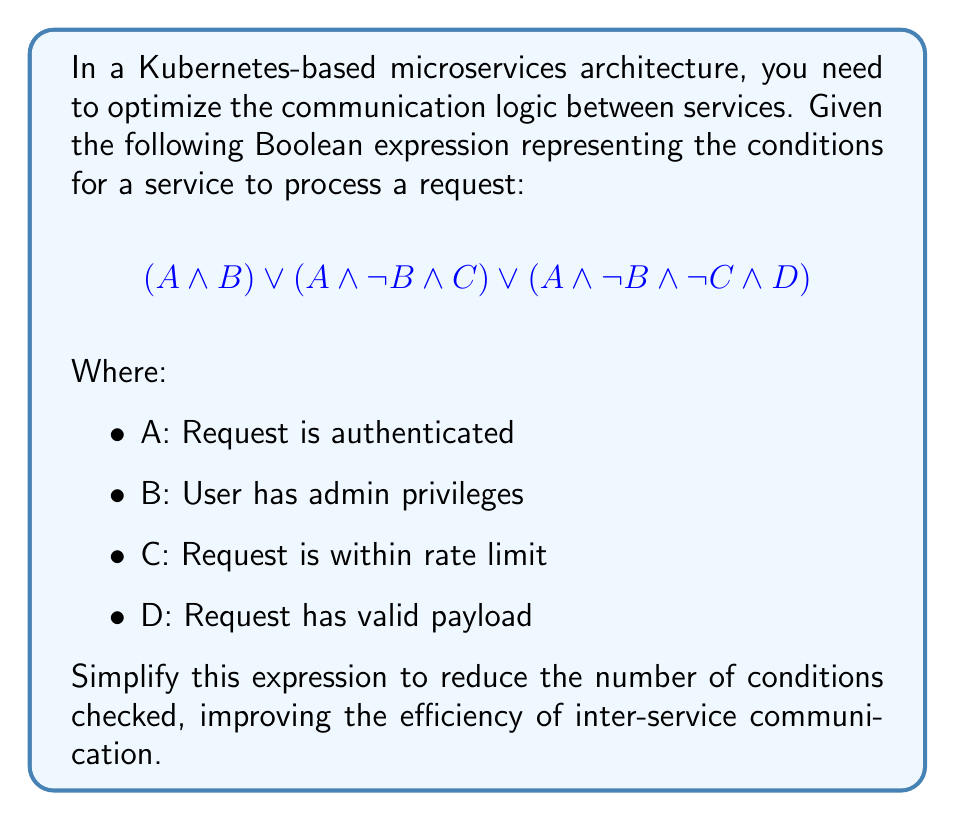Teach me how to tackle this problem. Let's simplify this expression step by step using Boolean algebra laws:

1) First, we can factor out A from all terms:
   $$A \land (B \lor (\lnot B \land C) \lor (\lnot B \land \lnot C \land D))$$

2) Now, let's focus on the part inside the parentheses:
   $$B \lor (\lnot B \land C) \lor (\lnot B \land \lnot C \land D)$$

3) We can apply the distributive law to the second and third terms:
   $$B \lor (\lnot B \land (C \lor (\lnot C \land D)))$$

4) Simplify the innermost parentheses using the absorption law:
   $$C \lor (\lnot C \land D) = C \lor D$$

5) Our expression now looks like:
   $$B \lor (\lnot B \land (C \lor D))$$

6) Apply the distributive law again:
   $$B \lor (\lnot B \land C) \lor (\lnot B \land D)$$

7) The term $(\lnot B \land C)$ can be eliminated because $B \lor (\lnot B \land C) = B \lor C$ (absorption law):
   $$B \lor C \lor (\lnot B \land D)$$

8) Finally, we can apply the absorption law one more time:
   $$(B \lor C) \lor (\lnot B \land D) = B \lor C \lor D$$

9) Putting it all together with the factored out A:
   $$A \land (B \lor C \lor D)$$

This simplified expression is logically equivalent to the original but requires checking fewer conditions.
Answer: $$A \land (B \lor C \lor D)$$ 